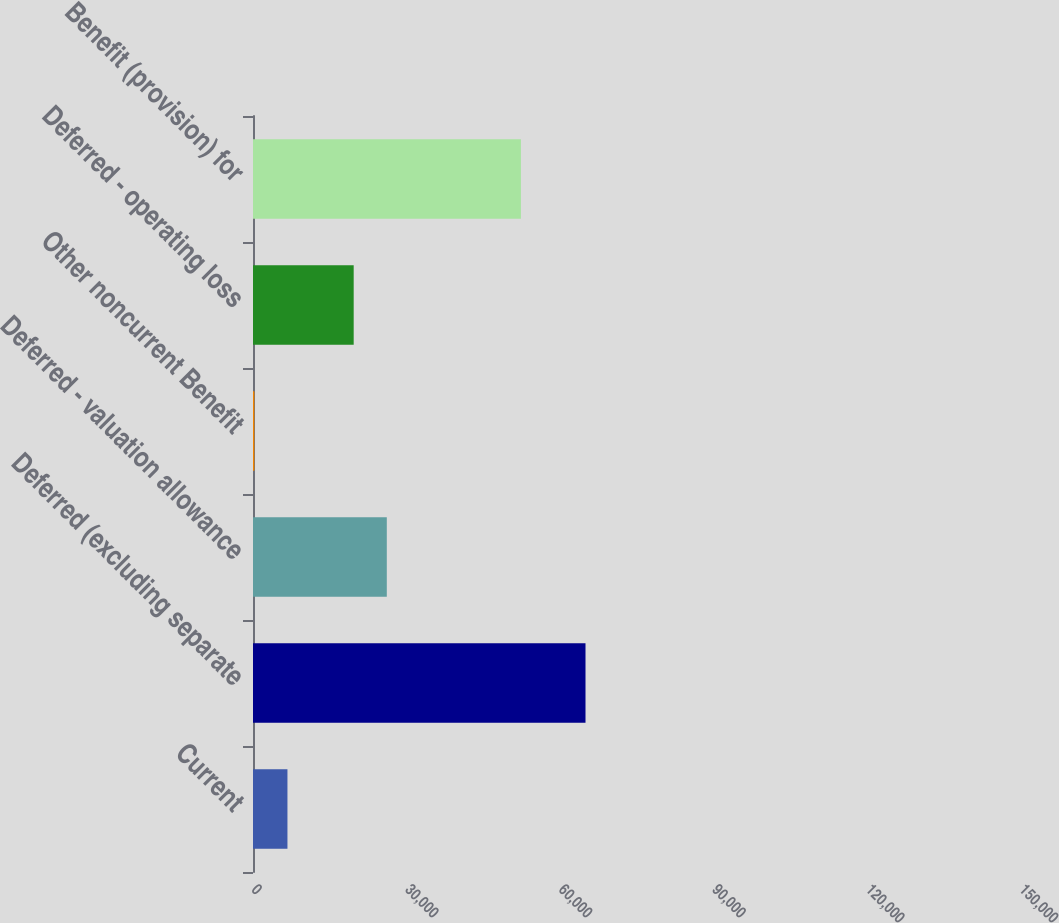<chart> <loc_0><loc_0><loc_500><loc_500><bar_chart><fcel>Current<fcel>Deferred (excluding separate<fcel>Deferred - valuation allowance<fcel>Other noncurrent Benefit<fcel>Deferred - operating loss<fcel>Benefit (provision) for<nl><fcel>14865.2<fcel>143468<fcel>57732.8<fcel>576<fcel>43443.6<fcel>115593<nl></chart> 